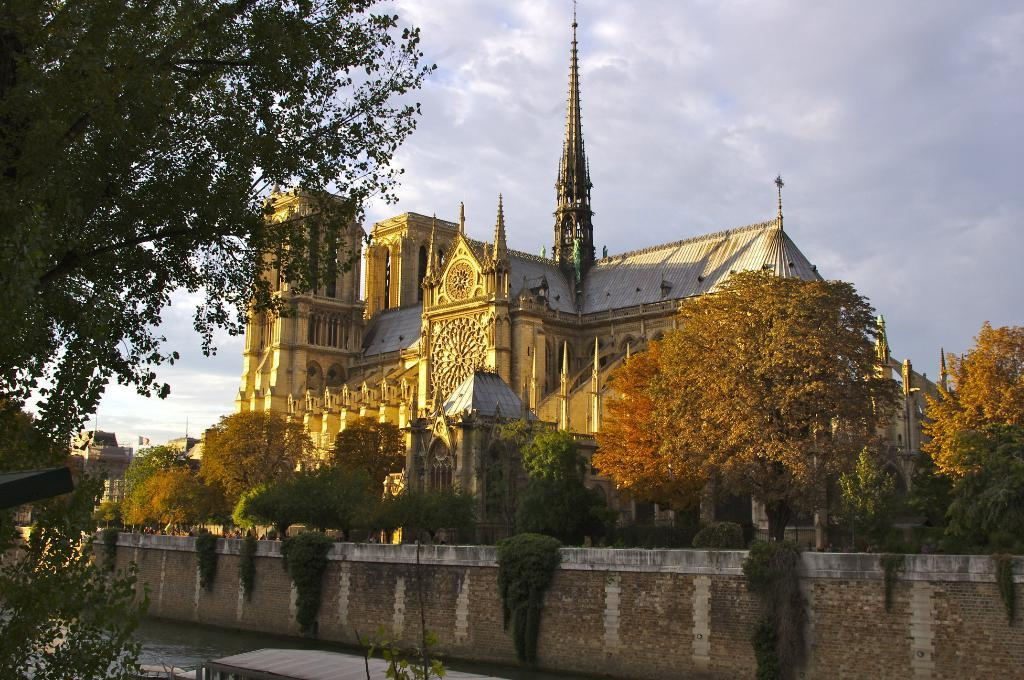What is the main structure in the center of the image? There is a building in the center of the image. What type of natural elements can be seen in the image? There are trees and water visible in the image. What is floating on the water in the image? There is a boat in the water. What type of barrier is present in the image? There is a wall in the image. What can be seen in the background of the image? The sky is visible in the background of the image. What type of camera is being used to take the picture of the plane in the image? There is no plane present in the image, and therefore no camera can be seen or mentioned. 